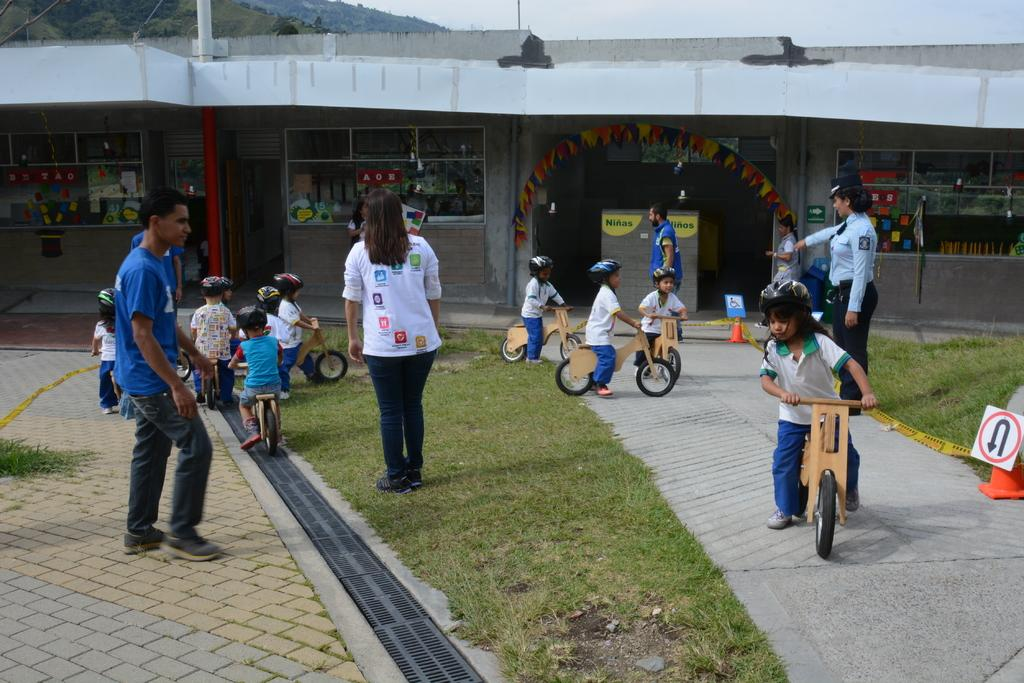What are the kids doing in the image? The kids are playing with cycles in the image. What safety precaution are the kids taking while riding their cycles? The kids are wearing helmets. Are there any other people present in the image? Yes, there are people standing nearby. What type of surface are the kids riding their cycles on? There is a grass lawn in the image. What can be seen in the background of the image? There is a building in the background of the image. Is there any signage visible in the image? Yes, there is a sign board in the image. What type of shop can be seen in the image? There is no shop present in the image; it features kids playing with cycles on a grass lawn. What type of air is being breathed by the kids in the image? The type of air being breathed by the kids cannot be determined from the image alone. 